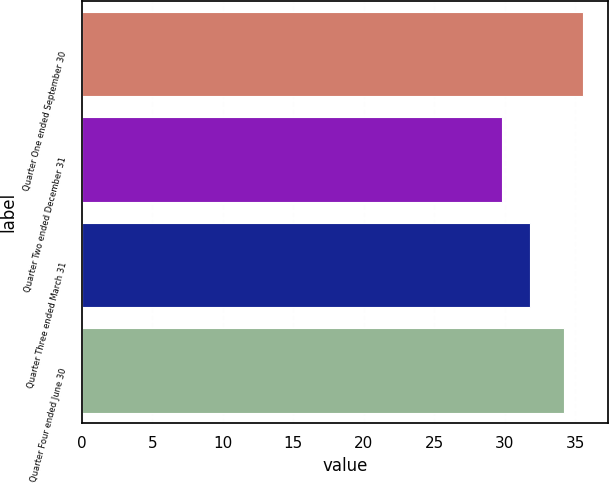Convert chart to OTSL. <chart><loc_0><loc_0><loc_500><loc_500><bar_chart><fcel>Quarter One ended September 30<fcel>Quarter Two ended December 31<fcel>Quarter Three ended March 31<fcel>Quarter Four ended June 30<nl><fcel>35.53<fcel>29.83<fcel>31.82<fcel>34.19<nl></chart> 